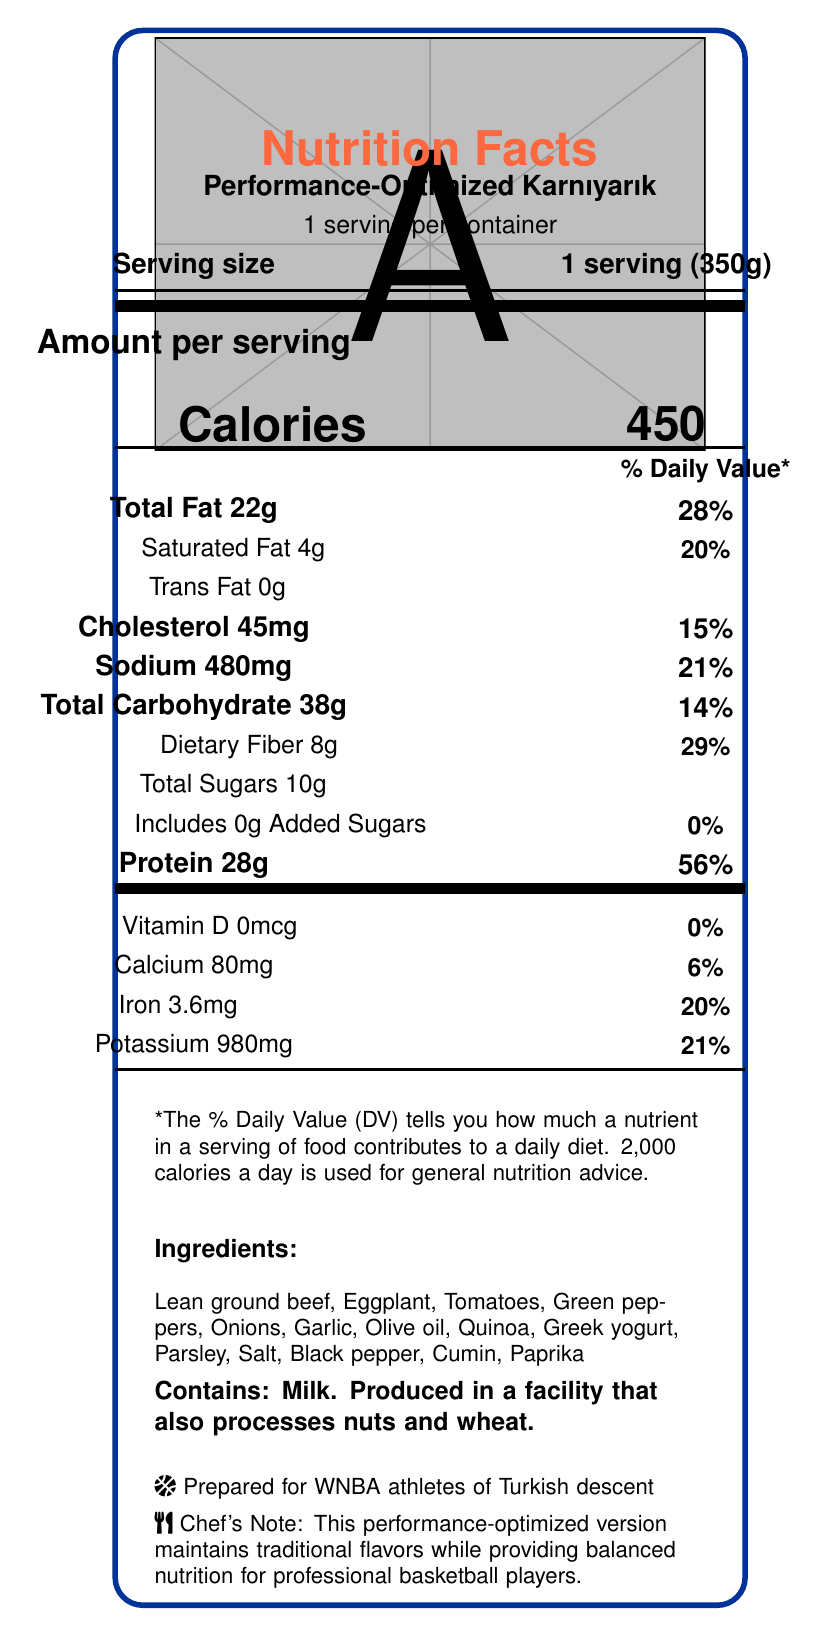what is the serving size of the Performance-Optimized Karnıyarık? The serving size is clearly stated in the document as "1 serving (350g)".
Answer: 1 serving (350g) how many calories are in one serving? The document specifies that one serving contains 450 calories.
Answer: 450 how much protein is in one serving? The document lists the protein content as 28g per serving.
Answer: 28g Which ingredient in the dish provides added protein and probiotics? The document mentions Greek yogurt as an ingredient, and it is known for containing both protein and probiotics.
Answer: Greek yogurt what percentage of the daily value is the dietary fiber content? According to the document, the dietary fiber content is 8g, which corresponds to 29% of the daily value.
Answer: 29% which vitamin is completely absent in this dish? The document specifies that the amount of Vitamin D is 0mcg, resulting in 0% of the daily value.
Answer: Vitamin D how many ingredients are listed for the Performance-Optimized Karnıyarık? Counting the ingredients listed in the document yields a total of 14 ingredients.
Answer: 14 what is the sodium content per serving? The document lists the sodium content as 480mg per serving.
Answer: 480mg which nutrient provides the highest % Daily Value per serving in this dish? The document details that protein provides 56% of the daily value per serving, which is the highest among the listed nutrients.
Answer: Protein Which of the following is one of the ingredients in the Performance-Optimized Karnıyarık? A. Cheese B. Quinoa C. Tofu The document includes quinoa as one of the ingredients.
Answer: B. Quinoa How much iron is in one serving of this dish? A. 2.4mg B. 3.6mg C. 4.2mg D. 1.8mg The iron content per serving is listed as 3.6mg.
Answer: B. 3.6mg True or False: The dish contains added sugars. The document specifies that there are 0g of added sugars, resulting in 0% of the daily value.
Answer: False describe the main information conveyed in the document. The document's primary goal is to inform about the nutritional aspects of the dish, ensuring it aligns with the needs of professional basketball players, maintaining traditional flavors while boosting key nutrients beneficial for athletic performance.
Answer: The document provides a detailed nutrition facts label for the Performance-Optimized Karnıyarık, a traditional Turkish dish adapted for optimal performance for WNBA athletes. It includes nutritional information, a list of ingredients, allergen information, and notes on its benefits for athletic performance. what is the daily recommended calorie intake used as a reference for the % Daily Value calculations? The document specifies that the % Daily Value calculations are based on a daily diet of 2,000 calories.
Answer: 2,000 calories what type of container should the dish be stored in for optimal freshness? The document states to "Keep refrigerated. Consume within 2 days for optimal freshness and nutritional value," but it does not specify the type of container to use.
Answer: Cannot be determined 